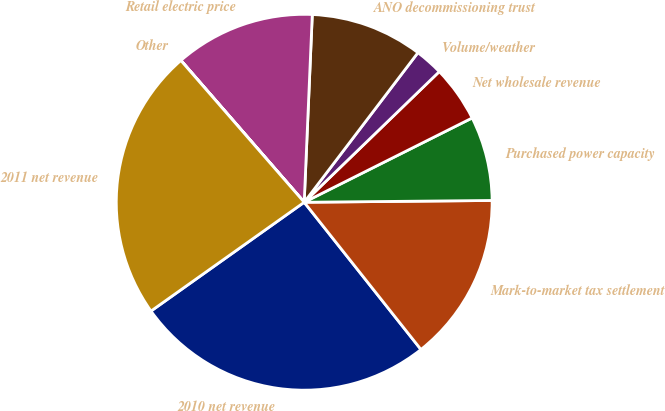<chart> <loc_0><loc_0><loc_500><loc_500><pie_chart><fcel>2010 net revenue<fcel>Mark-to-market tax settlement<fcel>Purchased power capacity<fcel>Net wholesale revenue<fcel>Volume/weather<fcel>ANO decommissioning trust<fcel>Retail electric price<fcel>Other<fcel>2011 net revenue<nl><fcel>25.84%<fcel>14.48%<fcel>7.25%<fcel>4.83%<fcel>2.42%<fcel>9.66%<fcel>12.07%<fcel>0.01%<fcel>23.43%<nl></chart> 